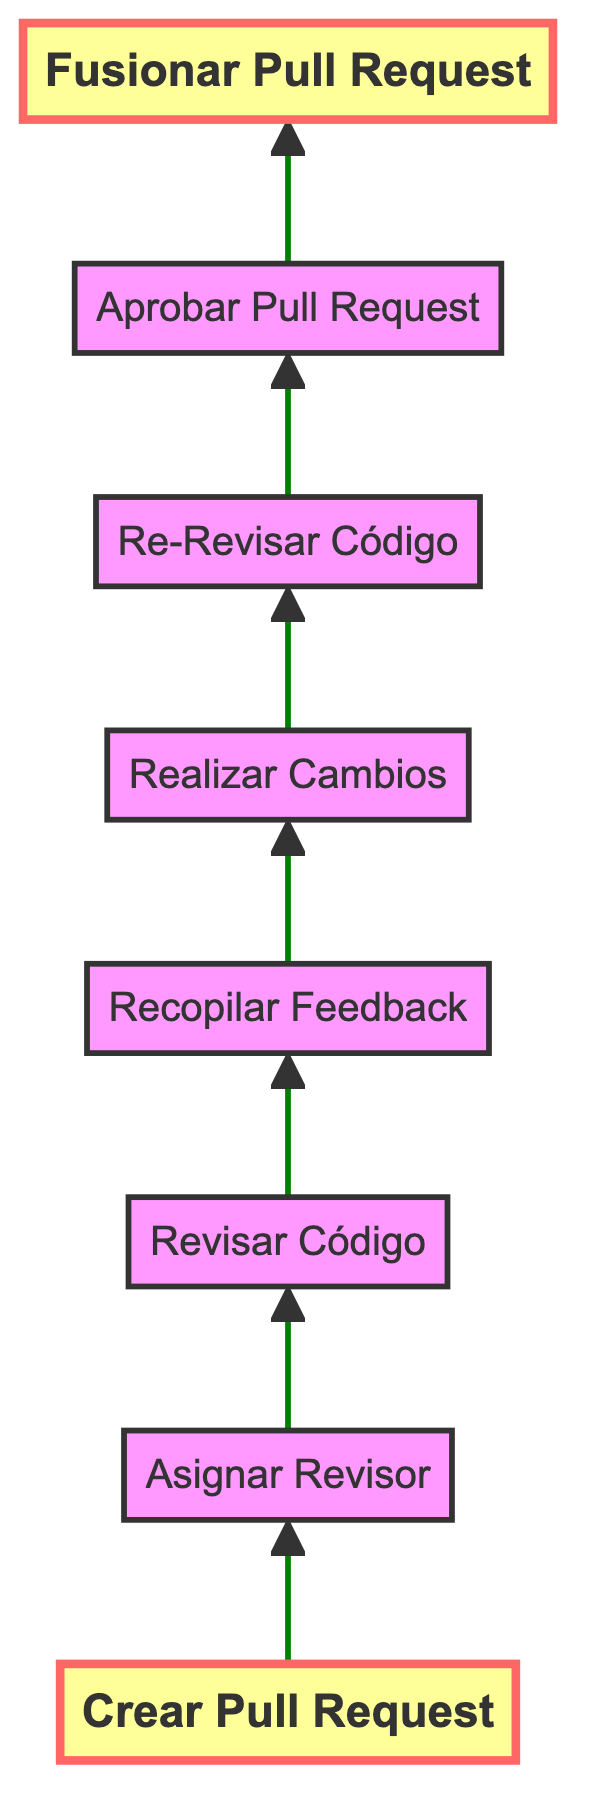What is the first step in the workflow? The first step is labeled "Crear Pull Request" which indicates that the workflow begins with a developer creating a pull request.
Answer: Crear Pull Request How many steps are there in total? By counting all the nodes in the diagram, including the start and end, there are eight steps in total to complete the workflow.
Answer: 8 What action follows "Recopilar Feedback"? The action that immediately follows "Recopilar Feedback" is "Realizar Cambios", indicating that the developer makes changes based on the feedback collected.
Answer: Realizar Cambios Who is responsible for assigning the reviewer? The node "Asignar Revisor" shows that it is either the project lead or the developer who assigns one or more reviewers to the pull request.
Answer: Project lead or developer What action is taken after "Re-Revisar Código"? The action taken after "Re-Revisar Código" is "Aprobar Pull Request", which implies the reviewers approve the changes if everything meets the criteria.
Answer: Aprobar Pull Request What is the endpoint of the workflow? The endpoint of the workflow is "Fusionar Pull Request", where the approved changes get merged into the main branch.
Answer: Fusionar Pull Request How many distinct actions are performed after creating the pull request? After creating the pull request, there are six distinct actions performed: Assign Reviewer, Review Code, Collect Feedback, Make Changes, Re-Review Code, and Approve Pull Request.
Answer: 6 Which node represents the step where changes are actually made by the developer? The step where the developer makes changes based on feedback is represented as "Realizar Cambios" in the diagram.
Answer: Realizar Cambios What is the relationship between "Recopilar Feedback" and "Aprobar Pull Request"? "Recopilar Feedback" comes before "Aprobar Pull Request", indicating that feedback must be collected and addressed before approval can happen.
Answer: Recopilar Feedback → Aprobar Pull Request 